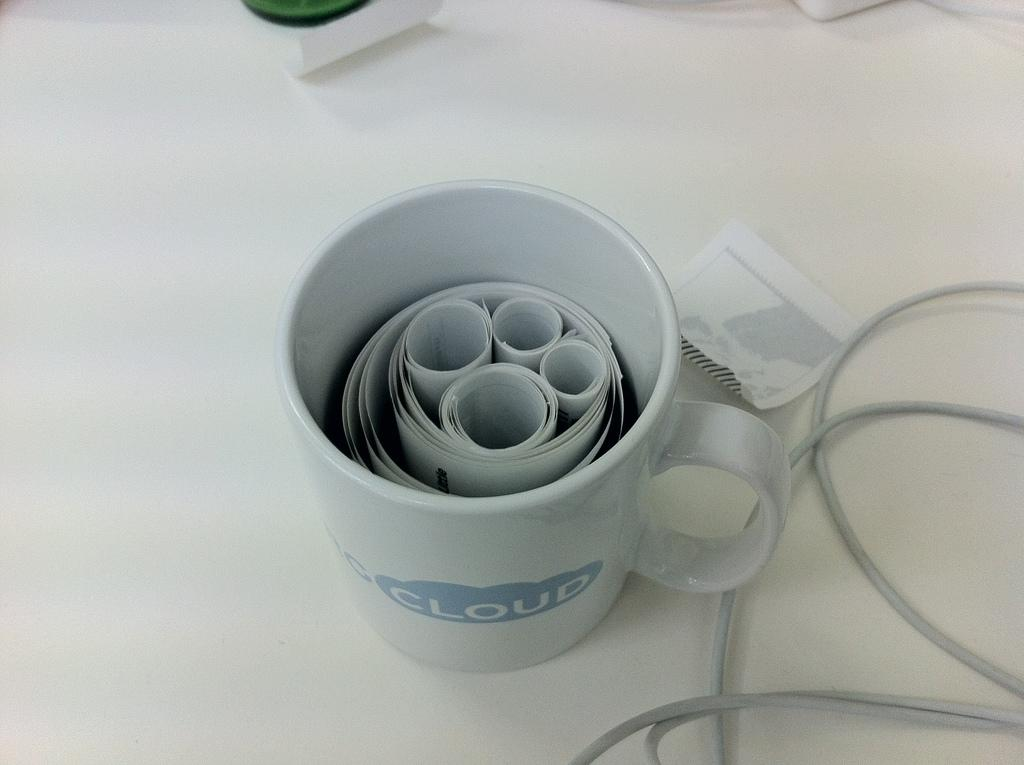What is in the coffee cup that is visible in the image? The coffee cup contains a paper roll in the image. Where is the coffee cup located in the image? The coffee cup is on a table in the image. What else is present beside the coffee cup on the table? There is a wire and a paper beside the coffee cup on the table. What type of quince is being served by the servant in the image? There is no quince or servant present in the image. Is there a lamp illuminating the coffee cup in the image? There is no lamp visible in the image. 